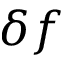Convert formula to latex. <formula><loc_0><loc_0><loc_500><loc_500>\delta f</formula> 